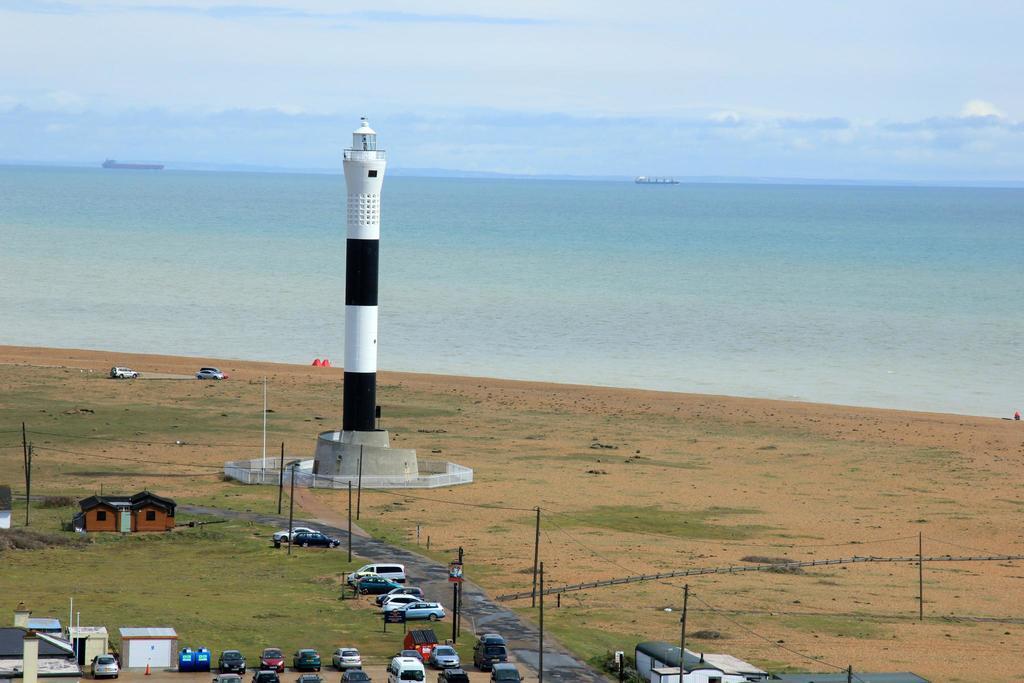Can you describe this image briefly? There is a lighthouse. Around that there is a railing. Near to that there is a road, poles, buildings and vehicles. In the background there is water and sky. 